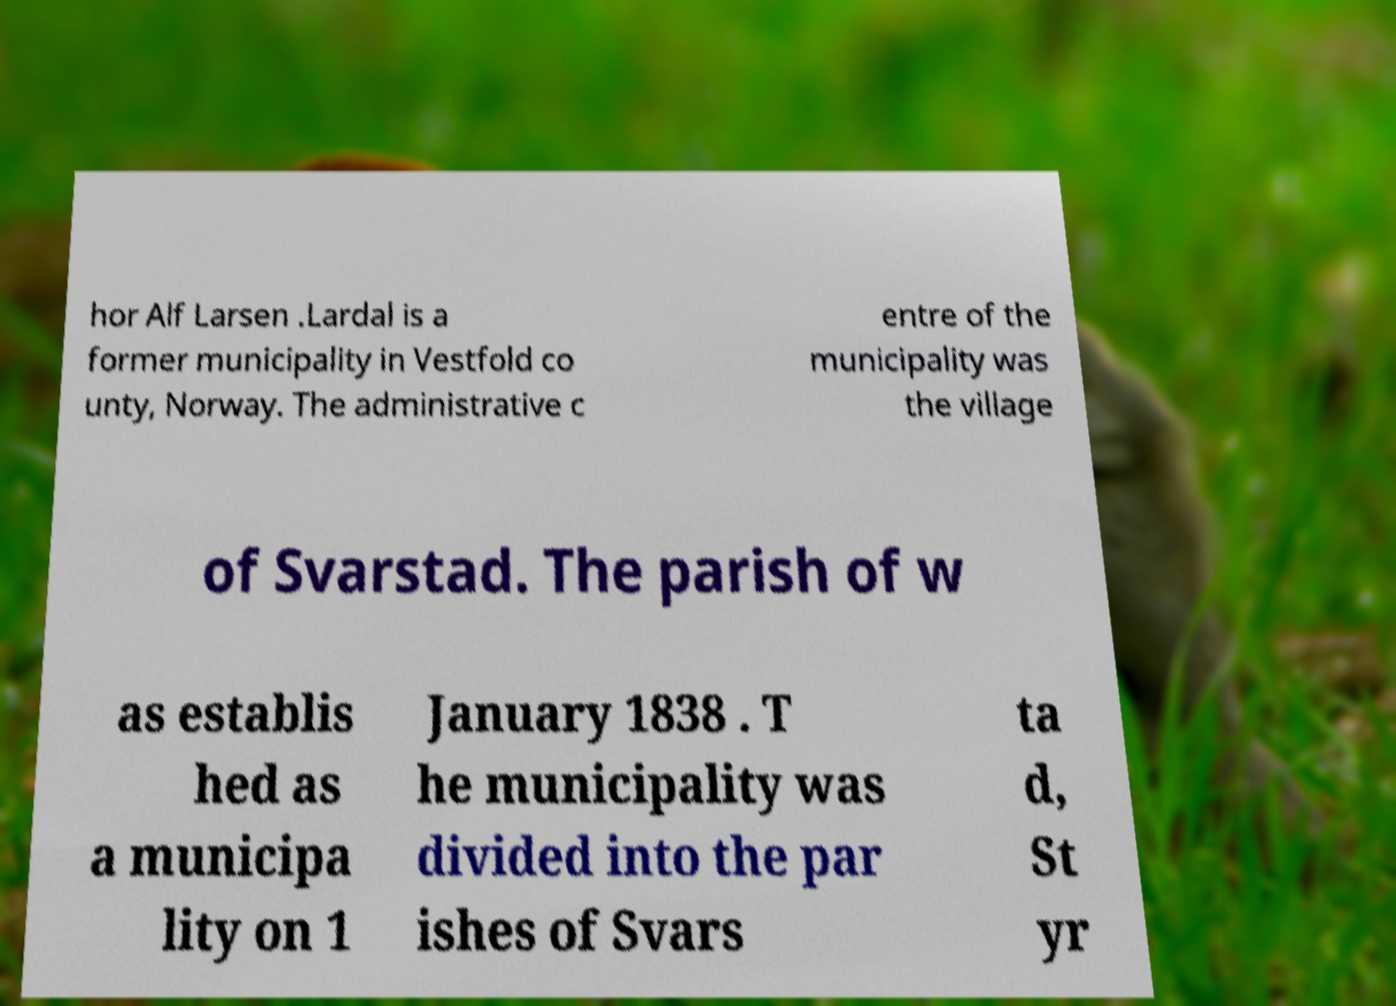There's text embedded in this image that I need extracted. Can you transcribe it verbatim? hor Alf Larsen .Lardal is a former municipality in Vestfold co unty, Norway. The administrative c entre of the municipality was the village of Svarstad. The parish of w as establis hed as a municipa lity on 1 January 1838 . T he municipality was divided into the par ishes of Svars ta d, St yr 